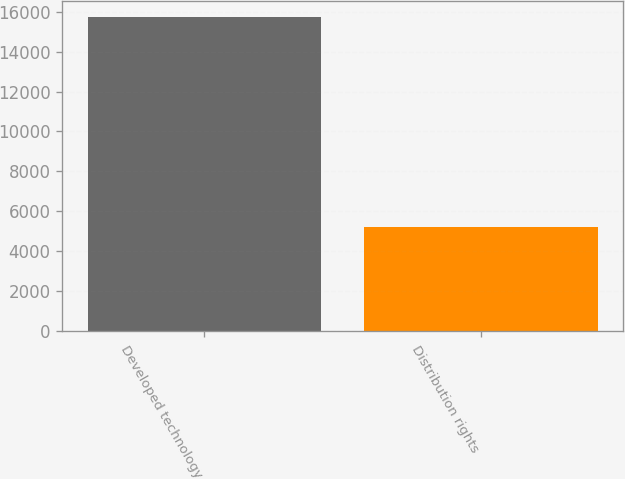Convert chart to OTSL. <chart><loc_0><loc_0><loc_500><loc_500><bar_chart><fcel>Developed technology<fcel>Distribution rights<nl><fcel>15729<fcel>5236<nl></chart> 